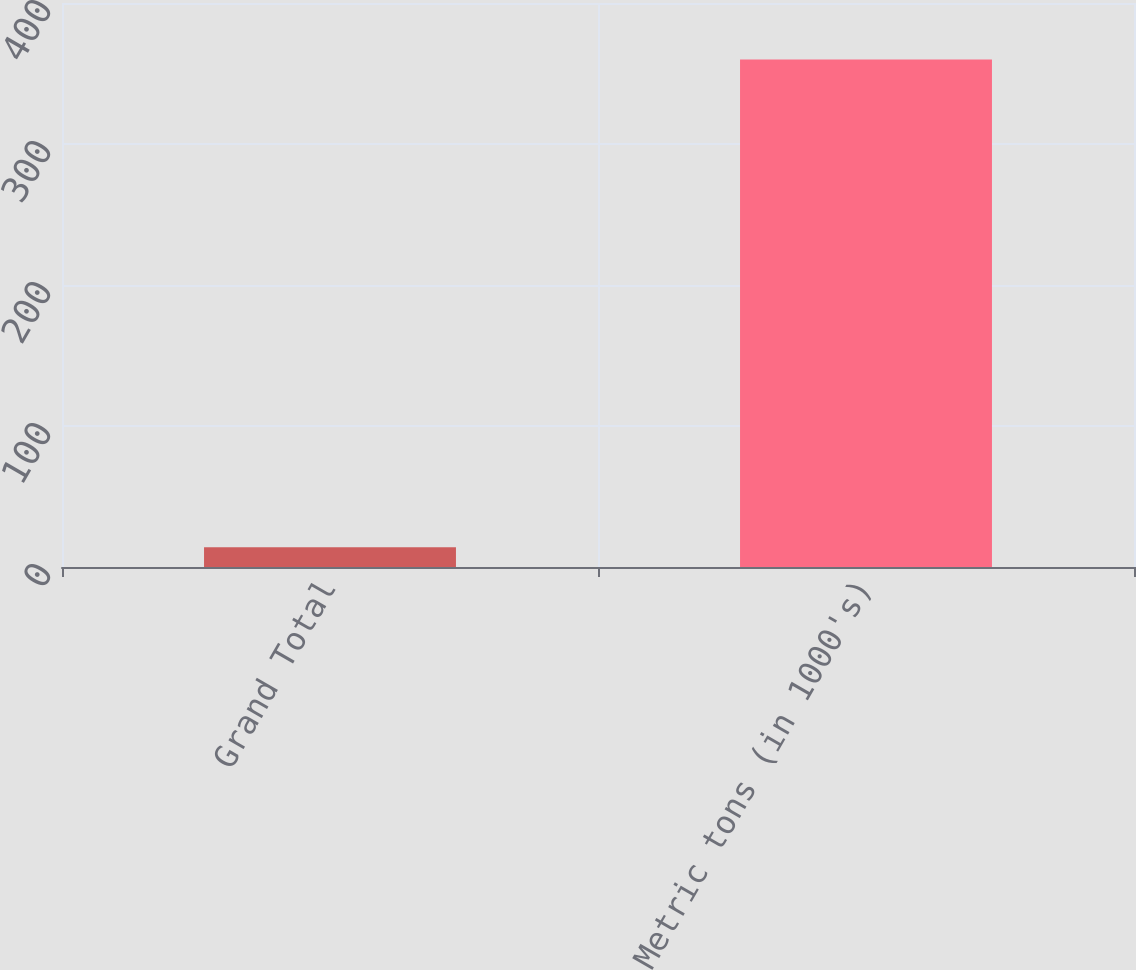Convert chart to OTSL. <chart><loc_0><loc_0><loc_500><loc_500><bar_chart><fcel>Grand Total<fcel>Metric tons (in 1000's)<nl><fcel>14<fcel>360<nl></chart> 